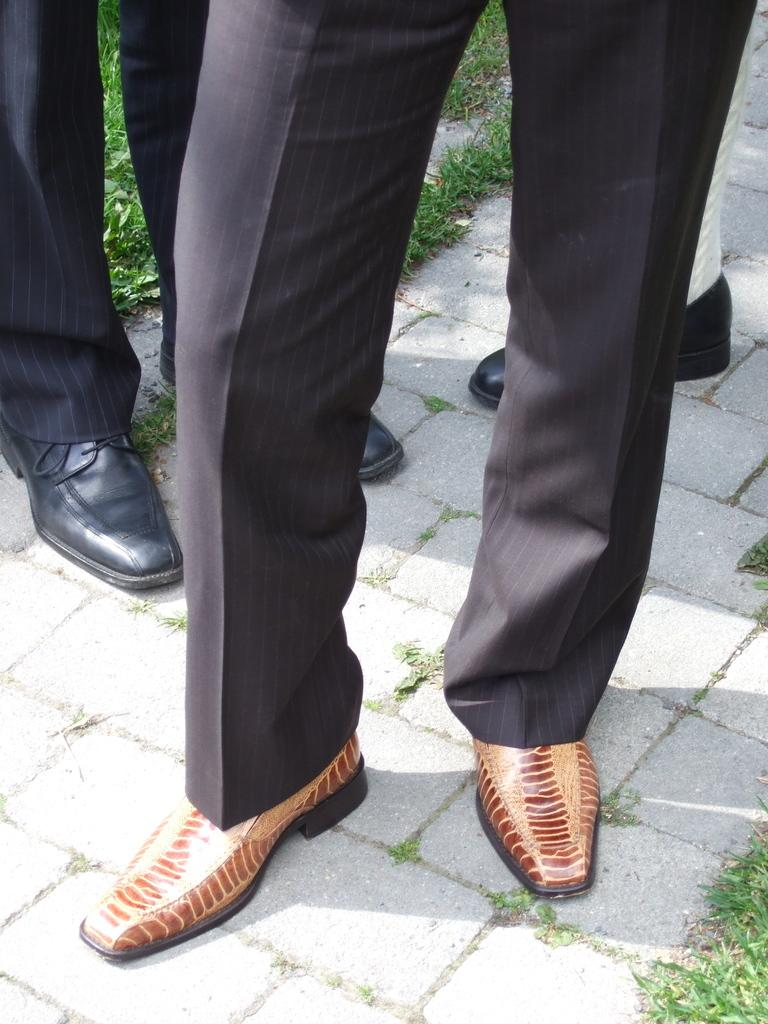What can be seen at the bottom of the image? Legs of people are visible in the image. What type of footwear can be seen in the image? Shoes are visible in the image. What colors are the shoes? The shoes are in brown and black colors. What type of natural environment is visible in the image? Green grass is visible in the image. What type of apple can be seen in the shade in the image? There is no apple or shade present in the image. 